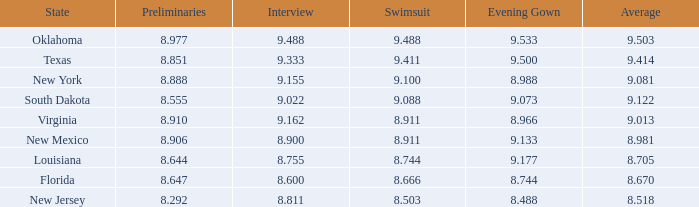 what's the preliminaries where evening gown is 8.988 8.888. 